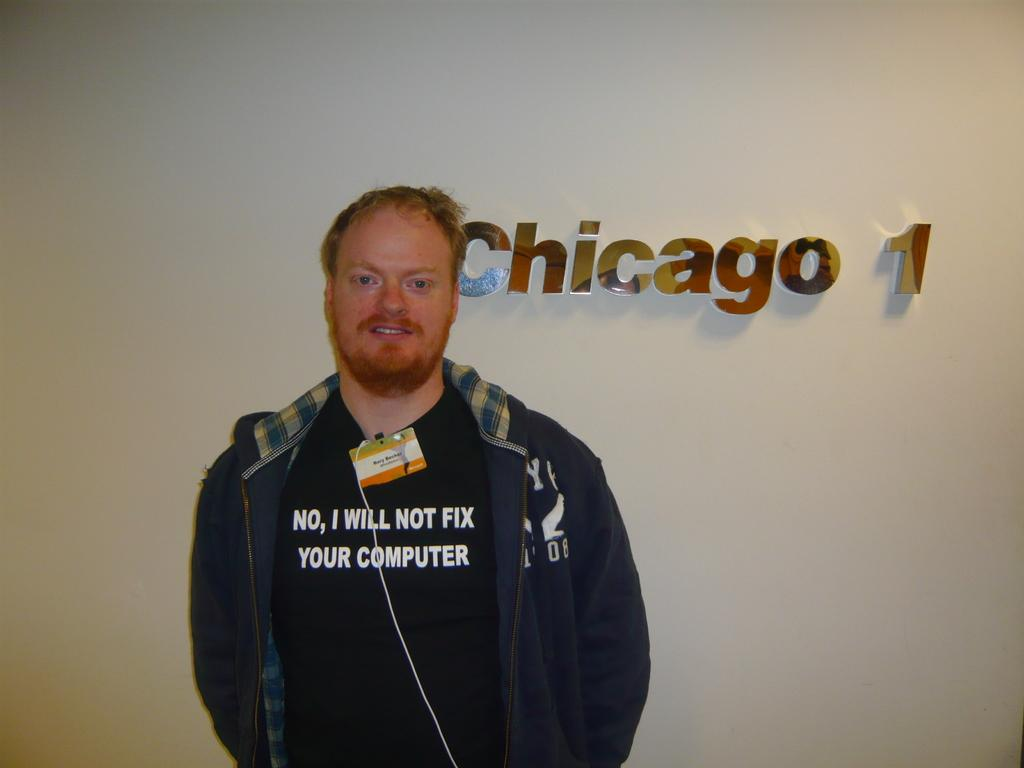What is the main subject of the image? There is a person standing in the center of the image. What is the person wearing? The person is wearing a jacket. What can be seen in the background of the image? There is a wall in the background of the image. How many snails can be seen crawling on the person's jacket in the image? There are no snails visible on the person's jacket in the image. What type of trip is the person taking in the image? There is no indication of a trip in the image; it simply shows a person standing with a wall in the background. 